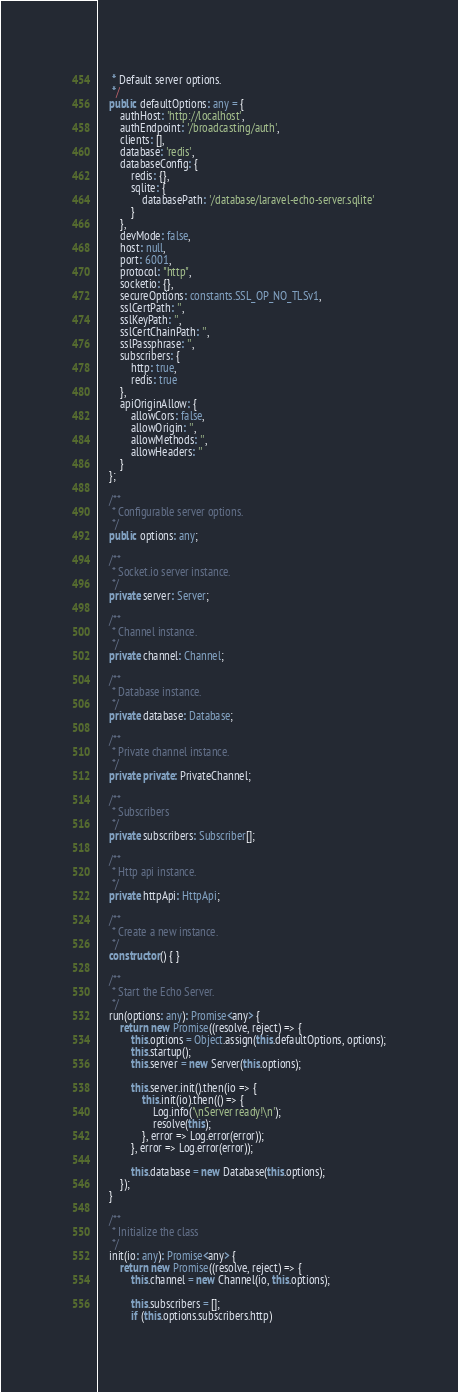Convert code to text. <code><loc_0><loc_0><loc_500><loc_500><_TypeScript_>     * Default server options.
     */
    public defaultOptions: any = {
        authHost: 'http://localhost',
        authEndpoint: '/broadcasting/auth',
        clients: [],
        database: 'redis',
        databaseConfig: {
            redis: {},
            sqlite: {
                databasePath: '/database/laravel-echo-server.sqlite'
            }
        },
        devMode: false,
        host: null,
        port: 6001,
        protocol: "http",
        socketio: {},
        secureOptions: constants.SSL_OP_NO_TLSv1,
        sslCertPath: '',
        sslKeyPath: '',
        sslCertChainPath: '',
        sslPassphrase: '',
        subscribers: {
            http: true,
            redis: true
        },
        apiOriginAllow: {
            allowCors: false,
            allowOrigin: '',
            allowMethods: '',
            allowHeaders: ''
        }
    };

    /**
     * Configurable server options.
     */
    public options: any;

    /**
     * Socket.io server instance.
     */
    private server: Server;

    /**
     * Channel instance.
     */
    private channel: Channel;

    /**
     * Database instance.
     */
    private database: Database;

    /**
     * Private channel instance.
     */
    private private: PrivateChannel;

    /**
     * Subscribers
     */
    private subscribers: Subscriber[];

    /**
     * Http api instance.
     */
    private httpApi: HttpApi;

    /**
     * Create a new instance.
     */
    constructor() { }

    /**
     * Start the Echo Server.
     */
    run(options: any): Promise<any> {
        return new Promise((resolve, reject) => {
            this.options = Object.assign(this.defaultOptions, options);
            this.startup();
            this.server = new Server(this.options);

            this.server.init().then(io => {
                this.init(io).then(() => {
                    Log.info('\nServer ready!\n');
                    resolve(this);
                }, error => Log.error(error));
            }, error => Log.error(error));

            this.database = new Database(this.options);
        });
    }

    /**
     * Initialize the class
     */
    init(io: any): Promise<any> {
        return new Promise((resolve, reject) => {
            this.channel = new Channel(io, this.options);

            this.subscribers = [];
            if (this.options.subscribers.http)</code> 